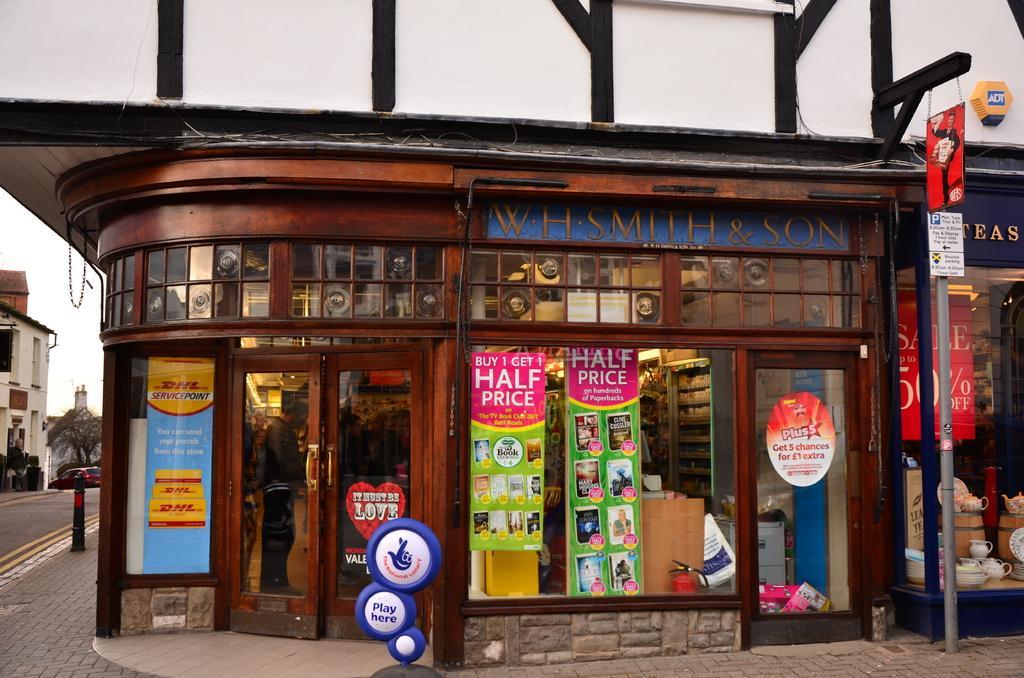Could you give a brief overview of what you see in this image? Here I can see a building. There are two doors through which we can see the inside view. Behind the doors there is a person standing. Here I can see few posts attached to the glass. On the right side there is a table on which few boxes and tea pots are placed and also there is a pole to which a board is attached. On the board, I can see some text. On the left side there is a car on the road and also there are buildings, trees and I can see the sky. 